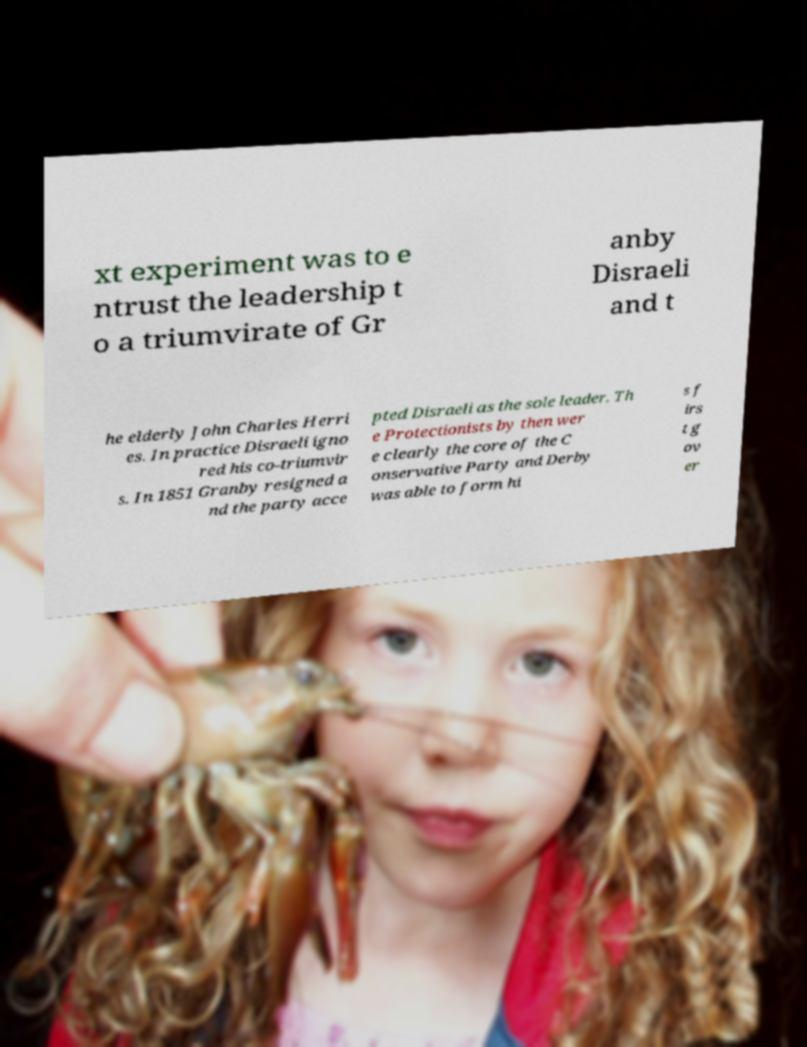Can you read and provide the text displayed in the image?This photo seems to have some interesting text. Can you extract and type it out for me? xt experiment was to e ntrust the leadership t o a triumvirate of Gr anby Disraeli and t he elderly John Charles Herri es. In practice Disraeli igno red his co-triumvir s. In 1851 Granby resigned a nd the party acce pted Disraeli as the sole leader. Th e Protectionists by then wer e clearly the core of the C onservative Party and Derby was able to form hi s f irs t g ov er 